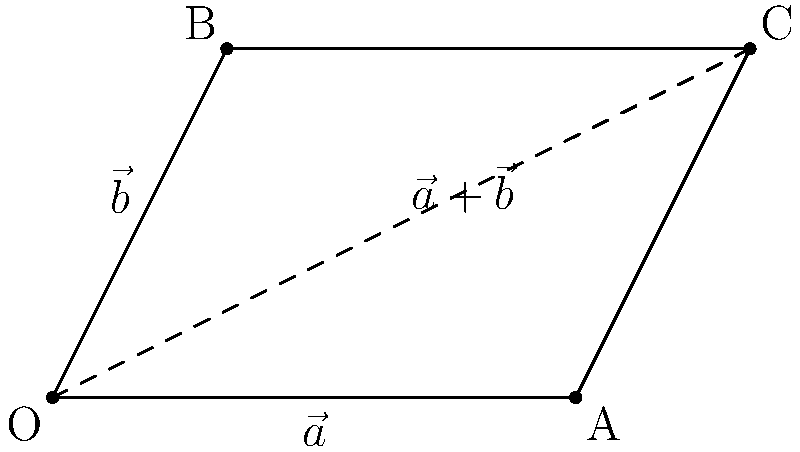In the parallelogram method of vector addition depicted above, vectors $\vec{a}$ and $\vec{b}$ are represented by adjacent sides of the parallelogram. What is the mathematical expression for the resultant vector $\vec{r}$ in terms of $\vec{a}$ and $\vec{b}$, and which line segment in the diagram represents this resultant vector? To solve this problem, let's follow these steps:

1. Recall the parallelogram method of vector addition:
   - The vectors to be added ($\vec{a}$ and $\vec{b}$) form two adjacent sides of a parallelogram.
   - The resultant vector $\vec{r}$ is represented by the diagonal of the parallelogram from the common origin of $\vec{a}$ and $\vec{b}$.

2. In the given diagram:
   - Vector $\vec{a}$ is represented by the line segment OA.
   - Vector $\vec{b}$ is represented by the line segment OB.
   - The parallelogram is formed by OACB.

3. The resultant vector $\vec{r}$ is represented by the diagonal OC of the parallelogram OACB.

4. Mathematically, the resultant vector $\vec{r}$ is the sum of vectors $\vec{a}$ and $\vec{b}$:

   $$\vec{r} = \vec{a} + \vec{b}$$

5. This equation is visually represented in the diagram by the fact that OC (the resultant) is equal to the sum of OA ($\vec{a}$) and AC (which is equal and parallel to OB, representing $\vec{b}$).

Therefore, the resultant vector $\vec{r}$ is mathematically expressed as $\vec{a} + \vec{b}$ and is represented by the line segment OC in the diagram.
Answer: $\vec{r} = \vec{a} + \vec{b}$, represented by OC 